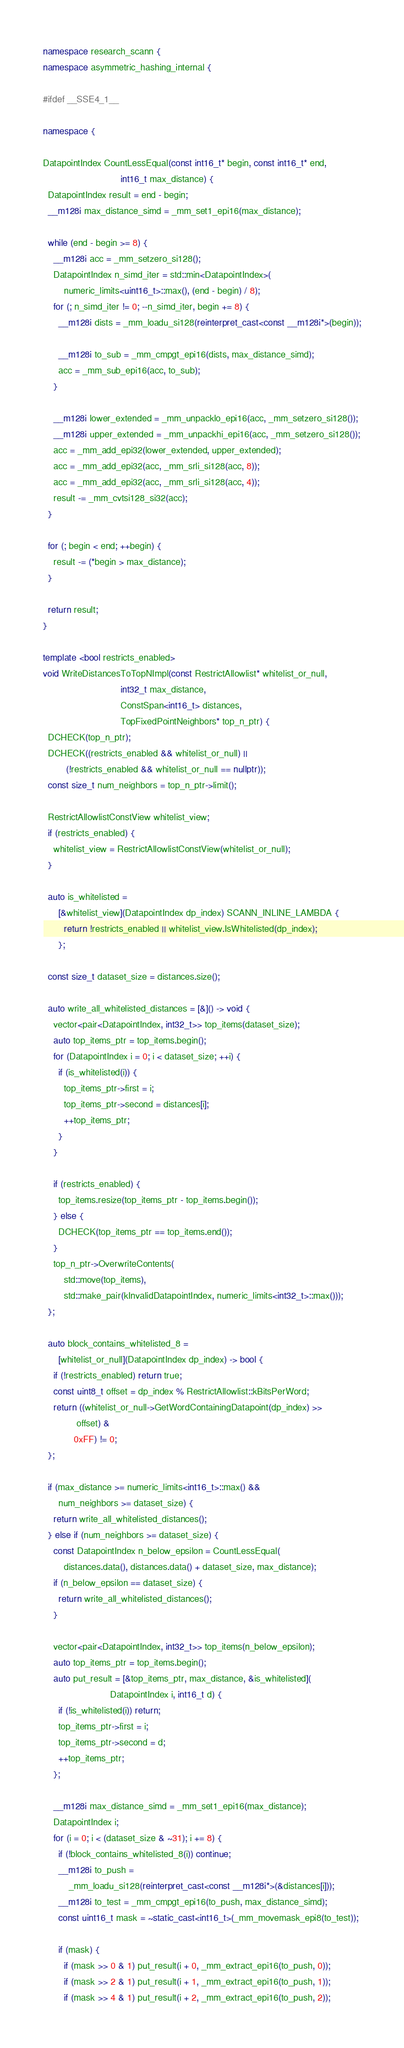Convert code to text. <code><loc_0><loc_0><loc_500><loc_500><_C++_>namespace research_scann {
namespace asymmetric_hashing_internal {

#ifdef __SSE4_1__

namespace {

DatapointIndex CountLessEqual(const int16_t* begin, const int16_t* end,
                              int16_t max_distance) {
  DatapointIndex result = end - begin;
  __m128i max_distance_simd = _mm_set1_epi16(max_distance);

  while (end - begin >= 8) {
    __m128i acc = _mm_setzero_si128();
    DatapointIndex n_simd_iter = std::min<DatapointIndex>(
        numeric_limits<uint16_t>::max(), (end - begin) / 8);
    for (; n_simd_iter != 0; --n_simd_iter, begin += 8) {
      __m128i dists = _mm_loadu_si128(reinterpret_cast<const __m128i*>(begin));

      __m128i to_sub = _mm_cmpgt_epi16(dists, max_distance_simd);
      acc = _mm_sub_epi16(acc, to_sub);
    }

    __m128i lower_extended = _mm_unpacklo_epi16(acc, _mm_setzero_si128());
    __m128i upper_extended = _mm_unpackhi_epi16(acc, _mm_setzero_si128());
    acc = _mm_add_epi32(lower_extended, upper_extended);
    acc = _mm_add_epi32(acc, _mm_srli_si128(acc, 8));
    acc = _mm_add_epi32(acc, _mm_srli_si128(acc, 4));
    result -= _mm_cvtsi128_si32(acc);
  }

  for (; begin < end; ++begin) {
    result -= (*begin > max_distance);
  }

  return result;
}

template <bool restricts_enabled>
void WriteDistancesToTopNImpl(const RestrictAllowlist* whitelist_or_null,
                              int32_t max_distance,
                              ConstSpan<int16_t> distances,
                              TopFixedPointNeighbors* top_n_ptr) {
  DCHECK(top_n_ptr);
  DCHECK((restricts_enabled && whitelist_or_null) ||
         (!restricts_enabled && whitelist_or_null == nullptr));
  const size_t num_neighbors = top_n_ptr->limit();

  RestrictAllowlistConstView whitelist_view;
  if (restricts_enabled) {
    whitelist_view = RestrictAllowlistConstView(whitelist_or_null);
  }

  auto is_whitelisted =
      [&whitelist_view](DatapointIndex dp_index) SCANN_INLINE_LAMBDA {
        return !restricts_enabled || whitelist_view.IsWhitelisted(dp_index);
      };

  const size_t dataset_size = distances.size();

  auto write_all_whitelisted_distances = [&]() -> void {
    vector<pair<DatapointIndex, int32_t>> top_items(dataset_size);
    auto top_items_ptr = top_items.begin();
    for (DatapointIndex i = 0; i < dataset_size; ++i) {
      if (is_whitelisted(i)) {
        top_items_ptr->first = i;
        top_items_ptr->second = distances[i];
        ++top_items_ptr;
      }
    }

    if (restricts_enabled) {
      top_items.resize(top_items_ptr - top_items.begin());
    } else {
      DCHECK(top_items_ptr == top_items.end());
    }
    top_n_ptr->OverwriteContents(
        std::move(top_items),
        std::make_pair(kInvalidDatapointIndex, numeric_limits<int32_t>::max()));
  };

  auto block_contains_whitelisted_8 =
      [whitelist_or_null](DatapointIndex dp_index) -> bool {
    if (!restricts_enabled) return true;
    const uint8_t offset = dp_index % RestrictAllowlist::kBitsPerWord;
    return ((whitelist_or_null->GetWordContainingDatapoint(dp_index) >>
             offset) &
            0xFF) != 0;
  };

  if (max_distance >= numeric_limits<int16_t>::max() &&
      num_neighbors >= dataset_size) {
    return write_all_whitelisted_distances();
  } else if (num_neighbors >= dataset_size) {
    const DatapointIndex n_below_epsilon = CountLessEqual(
        distances.data(), distances.data() + dataset_size, max_distance);
    if (n_below_epsilon == dataset_size) {
      return write_all_whitelisted_distances();
    }

    vector<pair<DatapointIndex, int32_t>> top_items(n_below_epsilon);
    auto top_items_ptr = top_items.begin();
    auto put_result = [&top_items_ptr, max_distance, &is_whitelisted](
                          DatapointIndex i, int16_t d) {
      if (!is_whitelisted(i)) return;
      top_items_ptr->first = i;
      top_items_ptr->second = d;
      ++top_items_ptr;
    };

    __m128i max_distance_simd = _mm_set1_epi16(max_distance);
    DatapointIndex i;
    for (i = 0; i < (dataset_size & ~31); i += 8) {
      if (!block_contains_whitelisted_8(i)) continue;
      __m128i to_push =
          _mm_loadu_si128(reinterpret_cast<const __m128i*>(&distances[i]));
      __m128i to_test = _mm_cmpgt_epi16(to_push, max_distance_simd);
      const uint16_t mask = ~static_cast<int16_t>(_mm_movemask_epi8(to_test));

      if (mask) {
        if (mask >> 0 & 1) put_result(i + 0, _mm_extract_epi16(to_push, 0));
        if (mask >> 2 & 1) put_result(i + 1, _mm_extract_epi16(to_push, 1));
        if (mask >> 4 & 1) put_result(i + 2, _mm_extract_epi16(to_push, 2));</code> 